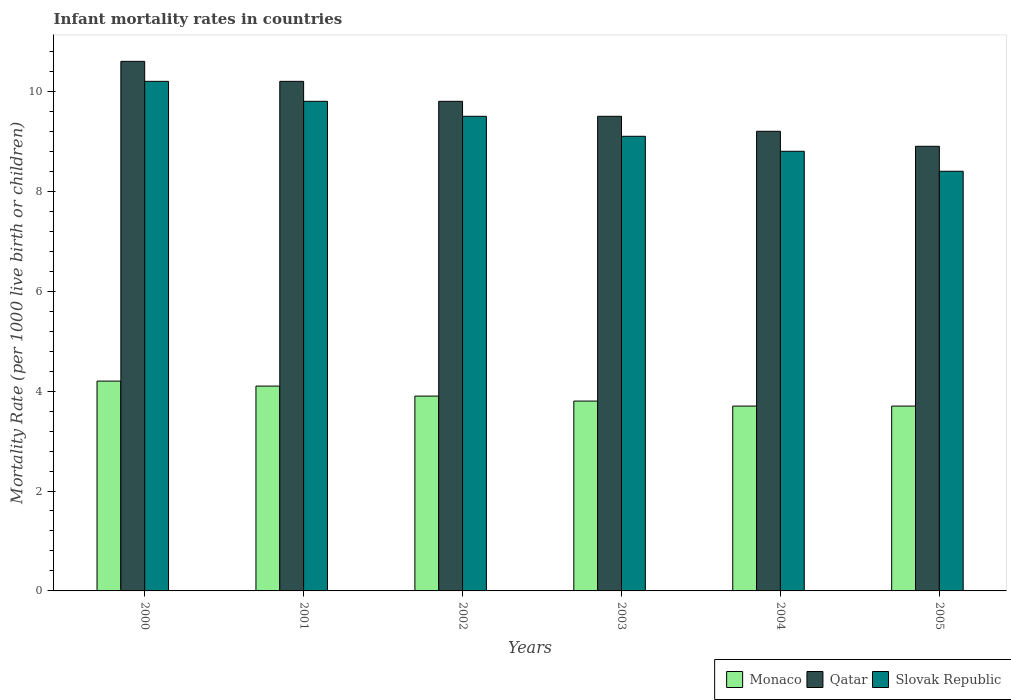How many groups of bars are there?
Offer a terse response. 6. What is the infant mortality rate in Qatar in 2004?
Keep it short and to the point. 9.2. What is the total infant mortality rate in Slovak Republic in the graph?
Your response must be concise. 55.8. What is the difference between the infant mortality rate in Monaco in 2000 and that in 2001?
Provide a short and direct response. 0.1. What is the difference between the infant mortality rate in Qatar in 2000 and the infant mortality rate in Slovak Republic in 2005?
Your answer should be compact. 2.2. What is the average infant mortality rate in Monaco per year?
Make the answer very short. 3.9. In how many years, is the infant mortality rate in Monaco greater than 7.6?
Provide a short and direct response. 0. What is the ratio of the infant mortality rate in Monaco in 2003 to that in 2005?
Offer a terse response. 1.03. What is the difference between the highest and the second highest infant mortality rate in Qatar?
Keep it short and to the point. 0.4. In how many years, is the infant mortality rate in Qatar greater than the average infant mortality rate in Qatar taken over all years?
Make the answer very short. 3. Is the sum of the infant mortality rate in Slovak Republic in 2001 and 2003 greater than the maximum infant mortality rate in Qatar across all years?
Your answer should be very brief. Yes. What does the 1st bar from the left in 2001 represents?
Your answer should be very brief. Monaco. What does the 1st bar from the right in 2002 represents?
Your response must be concise. Slovak Republic. Is it the case that in every year, the sum of the infant mortality rate in Qatar and infant mortality rate in Slovak Republic is greater than the infant mortality rate in Monaco?
Make the answer very short. Yes. How many bars are there?
Ensure brevity in your answer.  18. How many years are there in the graph?
Give a very brief answer. 6. Are the values on the major ticks of Y-axis written in scientific E-notation?
Your answer should be compact. No. Does the graph contain any zero values?
Offer a very short reply. No. How many legend labels are there?
Keep it short and to the point. 3. How are the legend labels stacked?
Offer a very short reply. Horizontal. What is the title of the graph?
Ensure brevity in your answer.  Infant mortality rates in countries. Does "Libya" appear as one of the legend labels in the graph?
Make the answer very short. No. What is the label or title of the X-axis?
Ensure brevity in your answer.  Years. What is the label or title of the Y-axis?
Your answer should be very brief. Mortality Rate (per 1000 live birth or children). What is the Mortality Rate (per 1000 live birth or children) of Slovak Republic in 2000?
Make the answer very short. 10.2. What is the Mortality Rate (per 1000 live birth or children) of Qatar in 2002?
Your response must be concise. 9.8. What is the Mortality Rate (per 1000 live birth or children) of Slovak Republic in 2003?
Your response must be concise. 9.1. What is the Mortality Rate (per 1000 live birth or children) of Qatar in 2004?
Offer a terse response. 9.2. What is the Mortality Rate (per 1000 live birth or children) in Qatar in 2005?
Offer a terse response. 8.9. Across all years, what is the maximum Mortality Rate (per 1000 live birth or children) in Monaco?
Ensure brevity in your answer.  4.2. Across all years, what is the maximum Mortality Rate (per 1000 live birth or children) of Slovak Republic?
Offer a terse response. 10.2. Across all years, what is the minimum Mortality Rate (per 1000 live birth or children) in Monaco?
Offer a terse response. 3.7. Across all years, what is the minimum Mortality Rate (per 1000 live birth or children) of Slovak Republic?
Provide a succinct answer. 8.4. What is the total Mortality Rate (per 1000 live birth or children) in Monaco in the graph?
Give a very brief answer. 23.4. What is the total Mortality Rate (per 1000 live birth or children) in Qatar in the graph?
Offer a terse response. 58.2. What is the total Mortality Rate (per 1000 live birth or children) in Slovak Republic in the graph?
Your response must be concise. 55.8. What is the difference between the Mortality Rate (per 1000 live birth or children) in Qatar in 2000 and that in 2001?
Give a very brief answer. 0.4. What is the difference between the Mortality Rate (per 1000 live birth or children) in Slovak Republic in 2000 and that in 2001?
Give a very brief answer. 0.4. What is the difference between the Mortality Rate (per 1000 live birth or children) in Monaco in 2000 and that in 2002?
Offer a terse response. 0.3. What is the difference between the Mortality Rate (per 1000 live birth or children) of Qatar in 2000 and that in 2003?
Give a very brief answer. 1.1. What is the difference between the Mortality Rate (per 1000 live birth or children) of Slovak Republic in 2000 and that in 2003?
Keep it short and to the point. 1.1. What is the difference between the Mortality Rate (per 1000 live birth or children) in Monaco in 2000 and that in 2004?
Your answer should be very brief. 0.5. What is the difference between the Mortality Rate (per 1000 live birth or children) of Monaco in 2000 and that in 2005?
Your response must be concise. 0.5. What is the difference between the Mortality Rate (per 1000 live birth or children) of Qatar in 2000 and that in 2005?
Provide a short and direct response. 1.7. What is the difference between the Mortality Rate (per 1000 live birth or children) of Slovak Republic in 2000 and that in 2005?
Give a very brief answer. 1.8. What is the difference between the Mortality Rate (per 1000 live birth or children) of Qatar in 2001 and that in 2002?
Provide a succinct answer. 0.4. What is the difference between the Mortality Rate (per 1000 live birth or children) of Monaco in 2001 and that in 2003?
Offer a terse response. 0.3. What is the difference between the Mortality Rate (per 1000 live birth or children) of Qatar in 2001 and that in 2004?
Provide a short and direct response. 1. What is the difference between the Mortality Rate (per 1000 live birth or children) in Slovak Republic in 2001 and that in 2004?
Your answer should be very brief. 1. What is the difference between the Mortality Rate (per 1000 live birth or children) of Qatar in 2001 and that in 2005?
Offer a terse response. 1.3. What is the difference between the Mortality Rate (per 1000 live birth or children) of Monaco in 2002 and that in 2003?
Keep it short and to the point. 0.1. What is the difference between the Mortality Rate (per 1000 live birth or children) of Slovak Republic in 2002 and that in 2003?
Give a very brief answer. 0.4. What is the difference between the Mortality Rate (per 1000 live birth or children) of Monaco in 2002 and that in 2004?
Give a very brief answer. 0.2. What is the difference between the Mortality Rate (per 1000 live birth or children) of Slovak Republic in 2002 and that in 2004?
Give a very brief answer. 0.7. What is the difference between the Mortality Rate (per 1000 live birth or children) of Monaco in 2002 and that in 2005?
Your answer should be very brief. 0.2. What is the difference between the Mortality Rate (per 1000 live birth or children) of Qatar in 2002 and that in 2005?
Make the answer very short. 0.9. What is the difference between the Mortality Rate (per 1000 live birth or children) of Qatar in 2003 and that in 2004?
Make the answer very short. 0.3. What is the difference between the Mortality Rate (per 1000 live birth or children) in Slovak Republic in 2003 and that in 2004?
Your response must be concise. 0.3. What is the difference between the Mortality Rate (per 1000 live birth or children) of Monaco in 2003 and that in 2005?
Your answer should be compact. 0.1. What is the difference between the Mortality Rate (per 1000 live birth or children) in Qatar in 2003 and that in 2005?
Your answer should be compact. 0.6. What is the difference between the Mortality Rate (per 1000 live birth or children) in Monaco in 2004 and that in 2005?
Make the answer very short. 0. What is the difference between the Mortality Rate (per 1000 live birth or children) in Slovak Republic in 2004 and that in 2005?
Provide a succinct answer. 0.4. What is the difference between the Mortality Rate (per 1000 live birth or children) in Monaco in 2000 and the Mortality Rate (per 1000 live birth or children) in Qatar in 2001?
Make the answer very short. -6. What is the difference between the Mortality Rate (per 1000 live birth or children) of Monaco in 2000 and the Mortality Rate (per 1000 live birth or children) of Slovak Republic in 2001?
Make the answer very short. -5.6. What is the difference between the Mortality Rate (per 1000 live birth or children) of Qatar in 2000 and the Mortality Rate (per 1000 live birth or children) of Slovak Republic in 2001?
Your answer should be compact. 0.8. What is the difference between the Mortality Rate (per 1000 live birth or children) in Monaco in 2000 and the Mortality Rate (per 1000 live birth or children) in Qatar in 2002?
Your response must be concise. -5.6. What is the difference between the Mortality Rate (per 1000 live birth or children) in Monaco in 2000 and the Mortality Rate (per 1000 live birth or children) in Slovak Republic in 2002?
Offer a terse response. -5.3. What is the difference between the Mortality Rate (per 1000 live birth or children) in Monaco in 2000 and the Mortality Rate (per 1000 live birth or children) in Qatar in 2003?
Your answer should be compact. -5.3. What is the difference between the Mortality Rate (per 1000 live birth or children) of Monaco in 2000 and the Mortality Rate (per 1000 live birth or children) of Qatar in 2004?
Provide a succinct answer. -5. What is the difference between the Mortality Rate (per 1000 live birth or children) in Monaco in 2000 and the Mortality Rate (per 1000 live birth or children) in Slovak Republic in 2004?
Provide a short and direct response. -4.6. What is the difference between the Mortality Rate (per 1000 live birth or children) in Qatar in 2000 and the Mortality Rate (per 1000 live birth or children) in Slovak Republic in 2004?
Your answer should be very brief. 1.8. What is the difference between the Mortality Rate (per 1000 live birth or children) of Monaco in 2000 and the Mortality Rate (per 1000 live birth or children) of Qatar in 2005?
Your answer should be very brief. -4.7. What is the difference between the Mortality Rate (per 1000 live birth or children) in Qatar in 2000 and the Mortality Rate (per 1000 live birth or children) in Slovak Republic in 2005?
Your response must be concise. 2.2. What is the difference between the Mortality Rate (per 1000 live birth or children) of Monaco in 2001 and the Mortality Rate (per 1000 live birth or children) of Qatar in 2002?
Ensure brevity in your answer.  -5.7. What is the difference between the Mortality Rate (per 1000 live birth or children) of Monaco in 2001 and the Mortality Rate (per 1000 live birth or children) of Qatar in 2003?
Offer a very short reply. -5.4. What is the difference between the Mortality Rate (per 1000 live birth or children) of Monaco in 2001 and the Mortality Rate (per 1000 live birth or children) of Slovak Republic in 2003?
Keep it short and to the point. -5. What is the difference between the Mortality Rate (per 1000 live birth or children) in Qatar in 2001 and the Mortality Rate (per 1000 live birth or children) in Slovak Republic in 2003?
Provide a succinct answer. 1.1. What is the difference between the Mortality Rate (per 1000 live birth or children) of Qatar in 2001 and the Mortality Rate (per 1000 live birth or children) of Slovak Republic in 2004?
Your response must be concise. 1.4. What is the difference between the Mortality Rate (per 1000 live birth or children) of Monaco in 2001 and the Mortality Rate (per 1000 live birth or children) of Slovak Republic in 2005?
Your answer should be very brief. -4.3. What is the difference between the Mortality Rate (per 1000 live birth or children) of Qatar in 2001 and the Mortality Rate (per 1000 live birth or children) of Slovak Republic in 2005?
Give a very brief answer. 1.8. What is the difference between the Mortality Rate (per 1000 live birth or children) of Monaco in 2002 and the Mortality Rate (per 1000 live birth or children) of Qatar in 2004?
Give a very brief answer. -5.3. What is the difference between the Mortality Rate (per 1000 live birth or children) in Monaco in 2002 and the Mortality Rate (per 1000 live birth or children) in Slovak Republic in 2004?
Keep it short and to the point. -4.9. What is the difference between the Mortality Rate (per 1000 live birth or children) of Monaco in 2003 and the Mortality Rate (per 1000 live birth or children) of Slovak Republic in 2005?
Offer a very short reply. -4.6. What is the difference between the Mortality Rate (per 1000 live birth or children) of Monaco in 2004 and the Mortality Rate (per 1000 live birth or children) of Slovak Republic in 2005?
Offer a terse response. -4.7. What is the average Mortality Rate (per 1000 live birth or children) in Qatar per year?
Ensure brevity in your answer.  9.7. In the year 2000, what is the difference between the Mortality Rate (per 1000 live birth or children) in Monaco and Mortality Rate (per 1000 live birth or children) in Qatar?
Offer a terse response. -6.4. In the year 2000, what is the difference between the Mortality Rate (per 1000 live birth or children) of Monaco and Mortality Rate (per 1000 live birth or children) of Slovak Republic?
Keep it short and to the point. -6. In the year 2001, what is the difference between the Mortality Rate (per 1000 live birth or children) of Monaco and Mortality Rate (per 1000 live birth or children) of Qatar?
Keep it short and to the point. -6.1. In the year 2002, what is the difference between the Mortality Rate (per 1000 live birth or children) of Monaco and Mortality Rate (per 1000 live birth or children) of Qatar?
Keep it short and to the point. -5.9. In the year 2002, what is the difference between the Mortality Rate (per 1000 live birth or children) of Monaco and Mortality Rate (per 1000 live birth or children) of Slovak Republic?
Ensure brevity in your answer.  -5.6. In the year 2002, what is the difference between the Mortality Rate (per 1000 live birth or children) of Qatar and Mortality Rate (per 1000 live birth or children) of Slovak Republic?
Offer a terse response. 0.3. In the year 2004, what is the difference between the Mortality Rate (per 1000 live birth or children) in Monaco and Mortality Rate (per 1000 live birth or children) in Qatar?
Keep it short and to the point. -5.5. What is the ratio of the Mortality Rate (per 1000 live birth or children) in Monaco in 2000 to that in 2001?
Provide a short and direct response. 1.02. What is the ratio of the Mortality Rate (per 1000 live birth or children) in Qatar in 2000 to that in 2001?
Your answer should be very brief. 1.04. What is the ratio of the Mortality Rate (per 1000 live birth or children) of Slovak Republic in 2000 to that in 2001?
Keep it short and to the point. 1.04. What is the ratio of the Mortality Rate (per 1000 live birth or children) in Monaco in 2000 to that in 2002?
Offer a terse response. 1.08. What is the ratio of the Mortality Rate (per 1000 live birth or children) in Qatar in 2000 to that in 2002?
Make the answer very short. 1.08. What is the ratio of the Mortality Rate (per 1000 live birth or children) in Slovak Republic in 2000 to that in 2002?
Your answer should be very brief. 1.07. What is the ratio of the Mortality Rate (per 1000 live birth or children) of Monaco in 2000 to that in 2003?
Provide a short and direct response. 1.11. What is the ratio of the Mortality Rate (per 1000 live birth or children) in Qatar in 2000 to that in 2003?
Ensure brevity in your answer.  1.12. What is the ratio of the Mortality Rate (per 1000 live birth or children) in Slovak Republic in 2000 to that in 2003?
Provide a succinct answer. 1.12. What is the ratio of the Mortality Rate (per 1000 live birth or children) in Monaco in 2000 to that in 2004?
Your answer should be very brief. 1.14. What is the ratio of the Mortality Rate (per 1000 live birth or children) in Qatar in 2000 to that in 2004?
Offer a terse response. 1.15. What is the ratio of the Mortality Rate (per 1000 live birth or children) in Slovak Republic in 2000 to that in 2004?
Provide a succinct answer. 1.16. What is the ratio of the Mortality Rate (per 1000 live birth or children) in Monaco in 2000 to that in 2005?
Provide a short and direct response. 1.14. What is the ratio of the Mortality Rate (per 1000 live birth or children) of Qatar in 2000 to that in 2005?
Give a very brief answer. 1.19. What is the ratio of the Mortality Rate (per 1000 live birth or children) of Slovak Republic in 2000 to that in 2005?
Your answer should be very brief. 1.21. What is the ratio of the Mortality Rate (per 1000 live birth or children) of Monaco in 2001 to that in 2002?
Ensure brevity in your answer.  1.05. What is the ratio of the Mortality Rate (per 1000 live birth or children) in Qatar in 2001 to that in 2002?
Offer a terse response. 1.04. What is the ratio of the Mortality Rate (per 1000 live birth or children) in Slovak Republic in 2001 to that in 2002?
Your answer should be very brief. 1.03. What is the ratio of the Mortality Rate (per 1000 live birth or children) of Monaco in 2001 to that in 2003?
Offer a terse response. 1.08. What is the ratio of the Mortality Rate (per 1000 live birth or children) of Qatar in 2001 to that in 2003?
Your answer should be compact. 1.07. What is the ratio of the Mortality Rate (per 1000 live birth or children) in Slovak Republic in 2001 to that in 2003?
Provide a short and direct response. 1.08. What is the ratio of the Mortality Rate (per 1000 live birth or children) of Monaco in 2001 to that in 2004?
Give a very brief answer. 1.11. What is the ratio of the Mortality Rate (per 1000 live birth or children) in Qatar in 2001 to that in 2004?
Your response must be concise. 1.11. What is the ratio of the Mortality Rate (per 1000 live birth or children) in Slovak Republic in 2001 to that in 2004?
Offer a terse response. 1.11. What is the ratio of the Mortality Rate (per 1000 live birth or children) of Monaco in 2001 to that in 2005?
Offer a terse response. 1.11. What is the ratio of the Mortality Rate (per 1000 live birth or children) in Qatar in 2001 to that in 2005?
Offer a very short reply. 1.15. What is the ratio of the Mortality Rate (per 1000 live birth or children) in Monaco in 2002 to that in 2003?
Your answer should be compact. 1.03. What is the ratio of the Mortality Rate (per 1000 live birth or children) of Qatar in 2002 to that in 2003?
Your answer should be very brief. 1.03. What is the ratio of the Mortality Rate (per 1000 live birth or children) in Slovak Republic in 2002 to that in 2003?
Give a very brief answer. 1.04. What is the ratio of the Mortality Rate (per 1000 live birth or children) of Monaco in 2002 to that in 2004?
Offer a terse response. 1.05. What is the ratio of the Mortality Rate (per 1000 live birth or children) in Qatar in 2002 to that in 2004?
Provide a succinct answer. 1.07. What is the ratio of the Mortality Rate (per 1000 live birth or children) in Slovak Republic in 2002 to that in 2004?
Your answer should be very brief. 1.08. What is the ratio of the Mortality Rate (per 1000 live birth or children) in Monaco in 2002 to that in 2005?
Offer a very short reply. 1.05. What is the ratio of the Mortality Rate (per 1000 live birth or children) of Qatar in 2002 to that in 2005?
Make the answer very short. 1.1. What is the ratio of the Mortality Rate (per 1000 live birth or children) in Slovak Republic in 2002 to that in 2005?
Keep it short and to the point. 1.13. What is the ratio of the Mortality Rate (per 1000 live birth or children) of Monaco in 2003 to that in 2004?
Provide a succinct answer. 1.03. What is the ratio of the Mortality Rate (per 1000 live birth or children) in Qatar in 2003 to that in 2004?
Your answer should be compact. 1.03. What is the ratio of the Mortality Rate (per 1000 live birth or children) of Slovak Republic in 2003 to that in 2004?
Your answer should be very brief. 1.03. What is the ratio of the Mortality Rate (per 1000 live birth or children) in Monaco in 2003 to that in 2005?
Make the answer very short. 1.03. What is the ratio of the Mortality Rate (per 1000 live birth or children) in Qatar in 2003 to that in 2005?
Keep it short and to the point. 1.07. What is the ratio of the Mortality Rate (per 1000 live birth or children) of Slovak Republic in 2003 to that in 2005?
Your response must be concise. 1.08. What is the ratio of the Mortality Rate (per 1000 live birth or children) in Monaco in 2004 to that in 2005?
Your response must be concise. 1. What is the ratio of the Mortality Rate (per 1000 live birth or children) in Qatar in 2004 to that in 2005?
Give a very brief answer. 1.03. What is the ratio of the Mortality Rate (per 1000 live birth or children) of Slovak Republic in 2004 to that in 2005?
Offer a very short reply. 1.05. What is the difference between the highest and the lowest Mortality Rate (per 1000 live birth or children) in Monaco?
Ensure brevity in your answer.  0.5. What is the difference between the highest and the lowest Mortality Rate (per 1000 live birth or children) of Qatar?
Your response must be concise. 1.7. What is the difference between the highest and the lowest Mortality Rate (per 1000 live birth or children) in Slovak Republic?
Give a very brief answer. 1.8. 